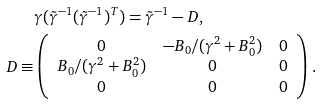Convert formula to latex. <formula><loc_0><loc_0><loc_500><loc_500>& \gamma ( \tilde { \gamma } ^ { - 1 } ( \tilde { \gamma } ^ { - 1 } ) ^ { T } ) = \tilde { \gamma } ^ { - 1 } - D , \\ D \equiv & \left ( \begin{array} { c c c } 0 & - B _ { 0 } / ( \gamma ^ { 2 } + B _ { 0 } ^ { 2 } ) & 0 \\ B _ { 0 } / ( \gamma ^ { 2 } + B _ { 0 } ^ { 2 } ) & 0 & 0 \\ 0 & 0 & 0 \end{array} \right ) .</formula> 